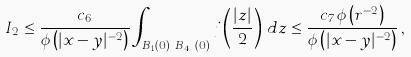<formula> <loc_0><loc_0><loc_500><loc_500>I _ { 2 } & \leq \frac { c _ { 6 } } { \phi \left ( | x - y | ^ { - 2 } \right ) } \int _ { B _ { 1 } ( 0 ) \ B _ { 4 r } ( 0 ) } j \left ( \frac { | z | } { 2 } \right ) \, d z \leq \frac { c _ { 7 } \phi \left ( r ^ { - 2 } \right ) } { \phi \left ( | x - y | ^ { - 2 } \right ) } \, ,</formula> 